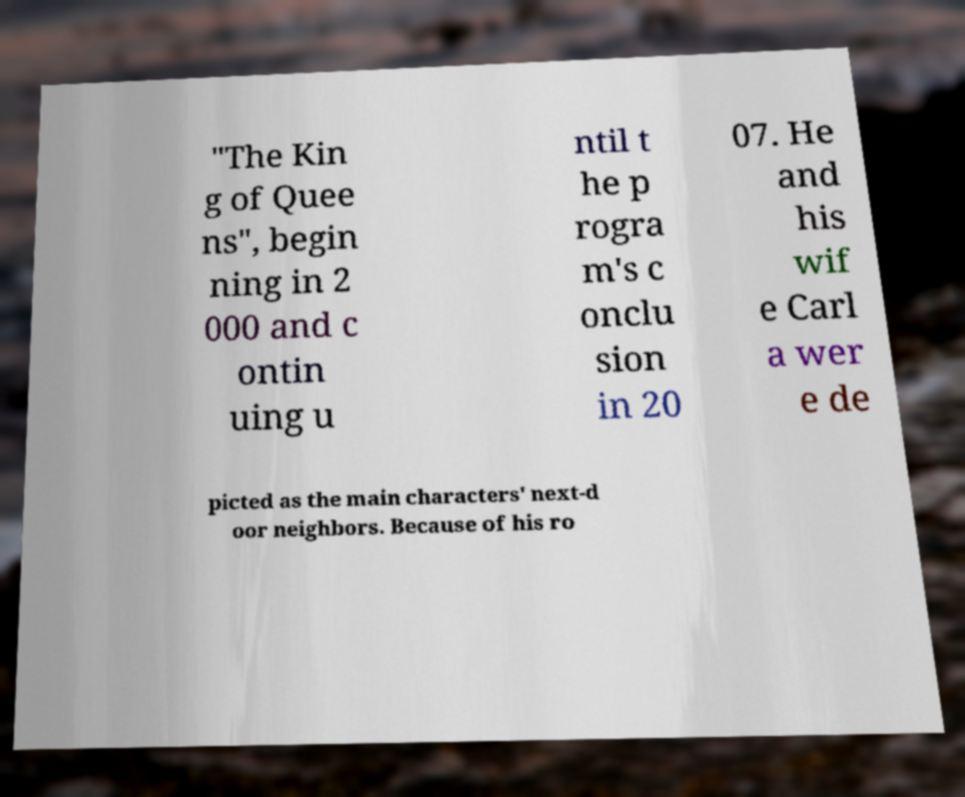What messages or text are displayed in this image? I need them in a readable, typed format. "The Kin g of Quee ns", begin ning in 2 000 and c ontin uing u ntil t he p rogra m's c onclu sion in 20 07. He and his wif e Carl a wer e de picted as the main characters' next-d oor neighbors. Because of his ro 